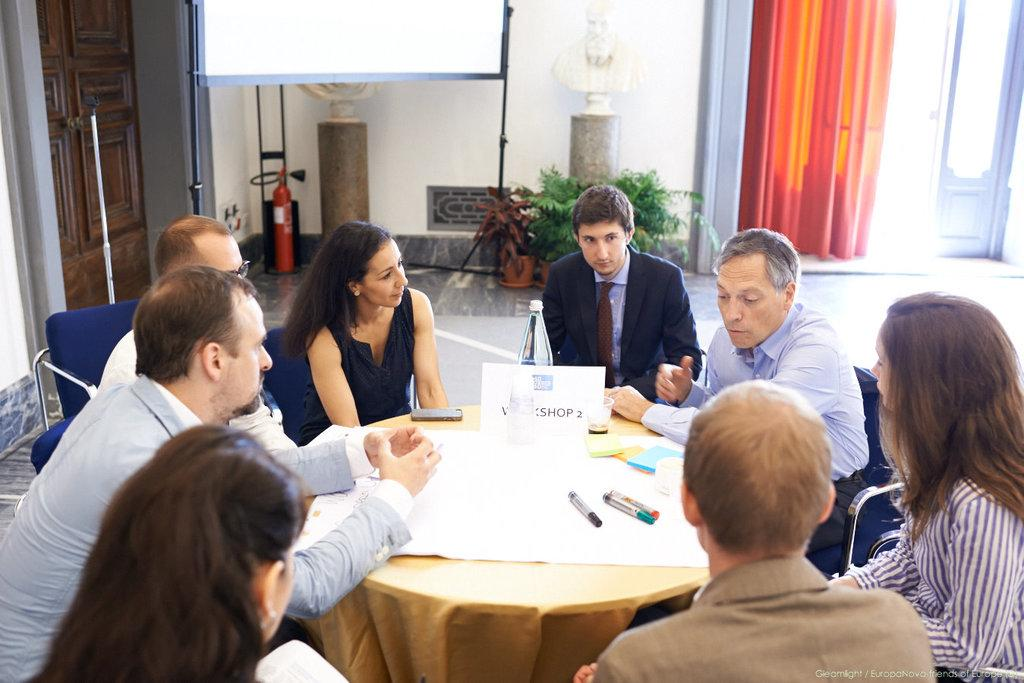What are the people in the image doing? The people in the image are sitting on chairs. What is on the table in the image? There are papers and markers on the table. What type of furniture is present in the image? There is a table and chairs in the image. What can be seen in the background of the image? There are plants in the image. What is the purpose of the whiteboard in the image? The whiteboard in the image is likely used for writing or drawing. What architectural features are present in the image? There is a door and a curtain in the image. How many ducks are swimming in the water in the image? There are no ducks or water present in the image. What type of voyage is the group of people planning in the image? There is no indication of a voyage or travel plans in the image. 